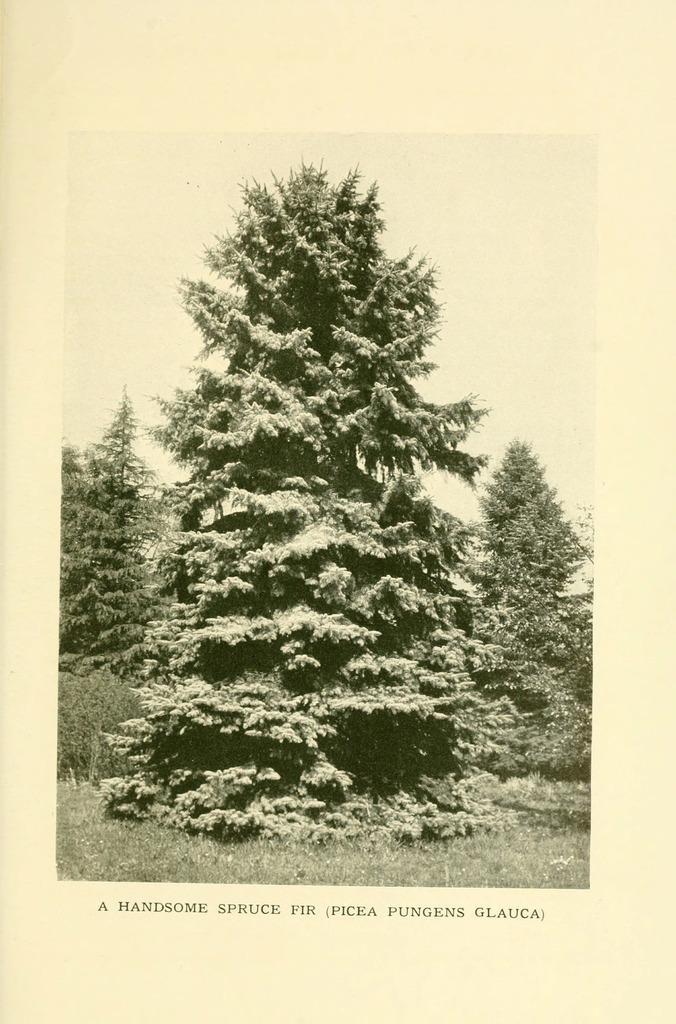How would you summarize this image in a sentence or two? In this image there are trees and there is grass and at the bottom of the image there is some text written on it. 